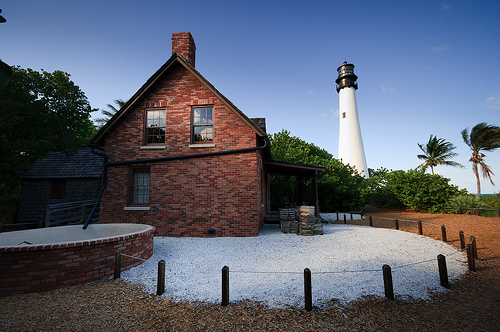<image>
Can you confirm if the gravel is on the cistern? No. The gravel is not positioned on the cistern. They may be near each other, but the gravel is not supported by or resting on top of the cistern. Where is the house in relation to the tree? Is it behind the tree? No. The house is not behind the tree. From this viewpoint, the house appears to be positioned elsewhere in the scene. Where is the house in relation to the pool? Is it next to the pool? Yes. The house is positioned adjacent to the pool, located nearby in the same general area. 